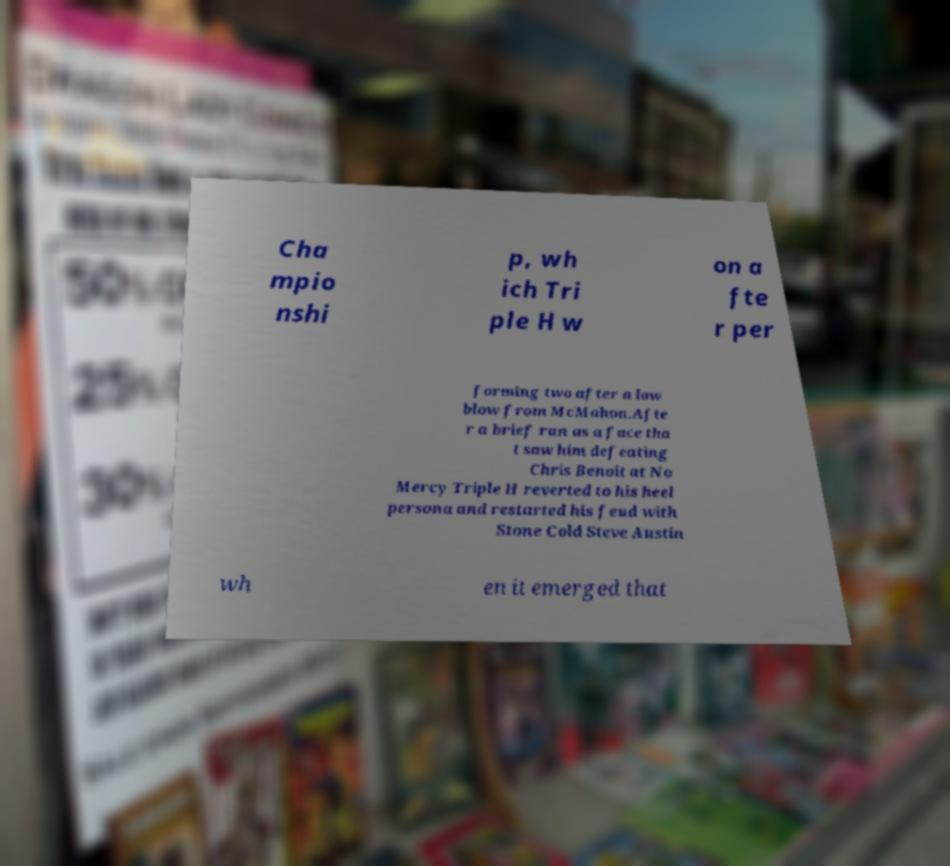Can you read and provide the text displayed in the image?This photo seems to have some interesting text. Can you extract and type it out for me? Cha mpio nshi p, wh ich Tri ple H w on a fte r per forming two after a low blow from McMahon.Afte r a brief run as a face tha t saw him defeating Chris Benoit at No Mercy Triple H reverted to his heel persona and restarted his feud with Stone Cold Steve Austin wh en it emerged that 